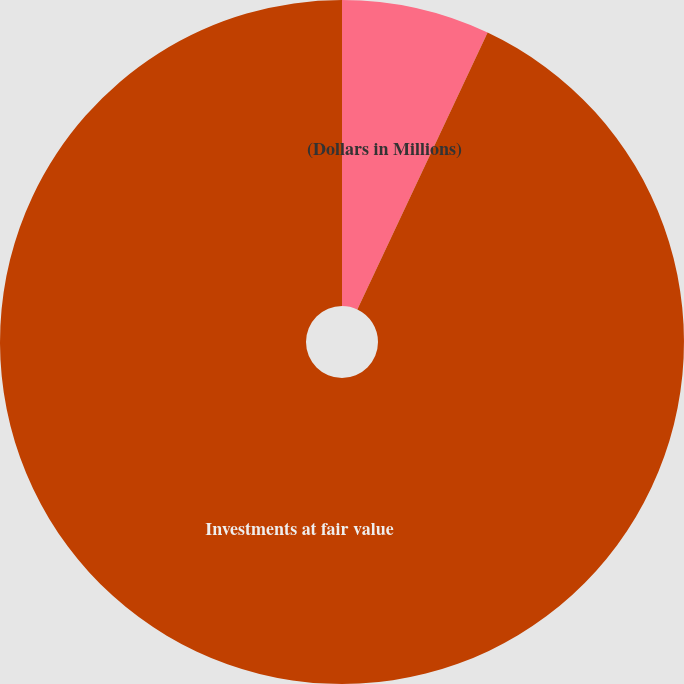<chart> <loc_0><loc_0><loc_500><loc_500><pie_chart><fcel>(Dollars in Millions)<fcel>Investments at fair value<nl><fcel>7.0%<fcel>93.0%<nl></chart> 